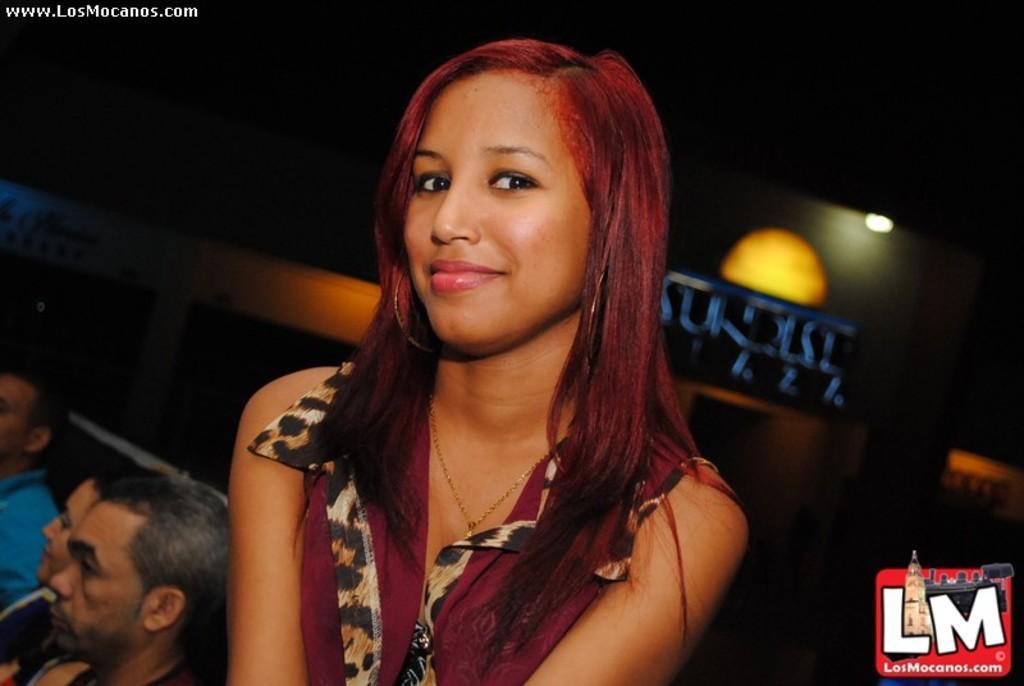Describe this image in one or two sentences. In this picture there is a girl in the center of the image and there are people in the bottom left side of the image, it seems to be a poster and a lamp in the background area of the image. 